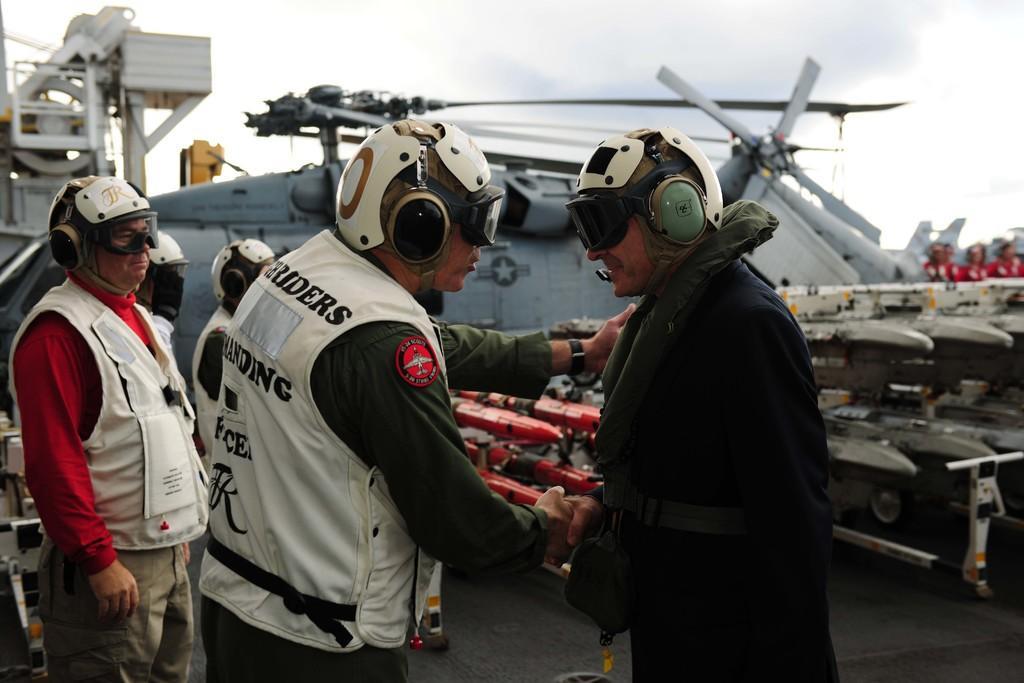Describe this image in one or two sentences. In this image we can see the people standing on the ground and we can see some aircrafts. In the background, we can see the sky. 